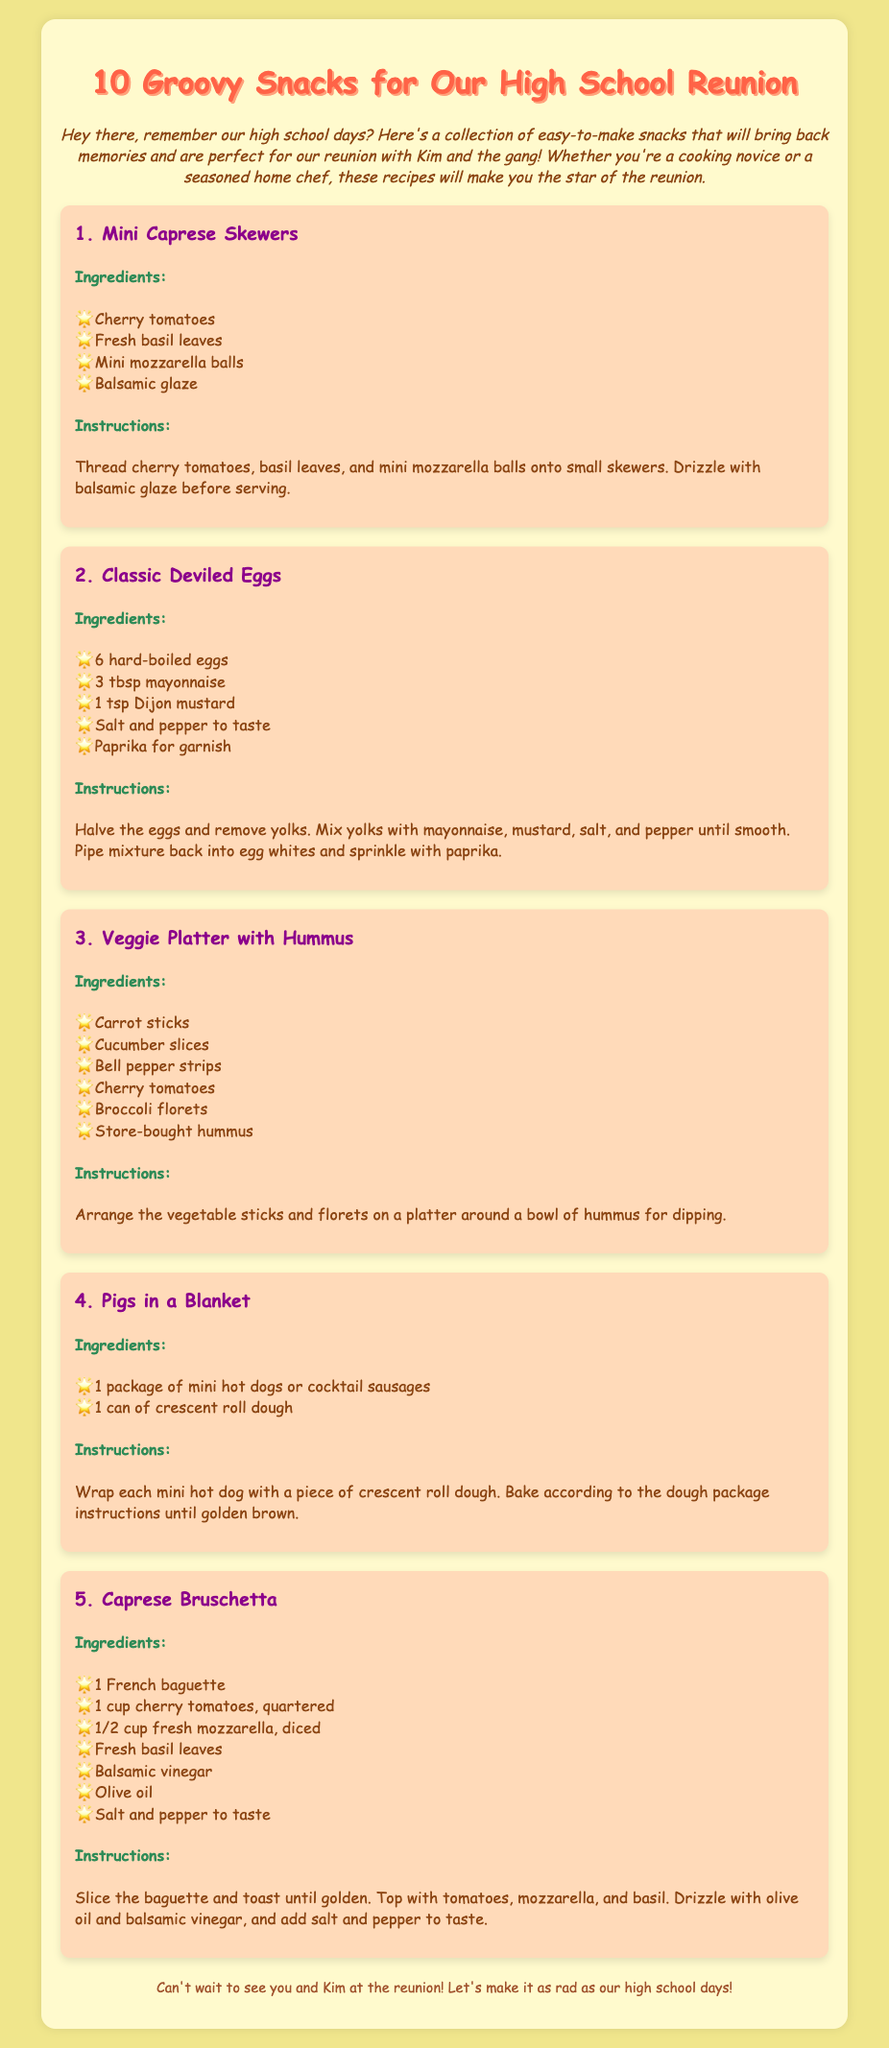What is the title of the document? The title of the document is presented in the header and states the purpose of the content.
Answer: 10 Groovy Snacks for Our High School Reunion How many ingredients are listed for the Classic Deviled Eggs? By counting the listed ingredients, we find that there are a total of five items.
Answer: 5 What is the first snack mentioned in the document? The first snack is highlighted under the recipe card section, showing its name clearly.
Answer: Mini Caprese Skewers What is the main ingredient for Pigs in a Blanket? The main ingredient is specified in the ingredients list for this recipe, which identifies the type of food used.
Answer: mini hot dogs What ingredient is used for drizzling in Caprese Bruschetta? The recipe explicitly states the ingredient that provides flavor and is to be drizzled on the dish.
Answer: olive oil 